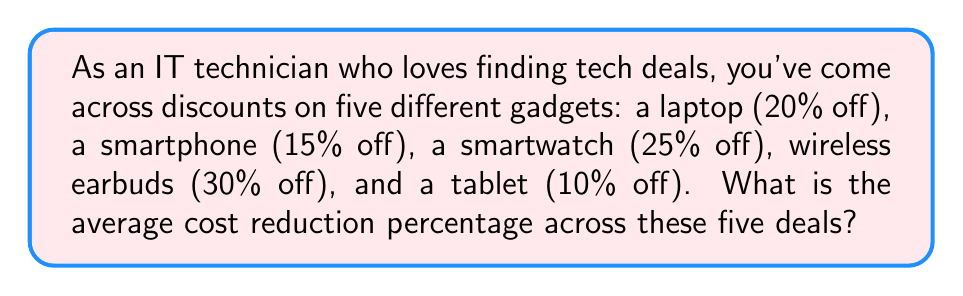Show me your answer to this math problem. To solve this problem, we need to follow these steps:

1. List all the discount percentages:
   - Laptop: 20%
   - Smartphone: 15%
   - Smartwatch: 25%
   - Wireless earbuds: 30%
   - Tablet: 10%

2. Calculate the sum of all discount percentages:
   $$20\% + 15\% + 25\% + 30\% + 10\% = 100\%$$

3. Count the total number of items:
   There are 5 items in total.

4. Calculate the average by dividing the sum by the number of items:
   $$\text{Average} = \frac{\text{Sum of percentages}}{\text{Number of items}} = \frac{100\%}{5} = 20\%$$

Therefore, the average cost reduction percentage across these five deals is 20%.
Answer: 20% 